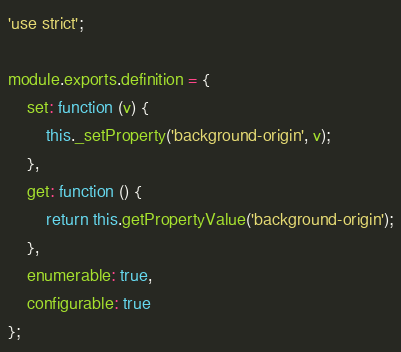Convert code to text. <code><loc_0><loc_0><loc_500><loc_500><_JavaScript_>'use strict';

module.exports.definition = {
    set: function (v) {
        this._setProperty('background-origin', v);
    },
    get: function () {
        return this.getPropertyValue('background-origin');
    },
    enumerable: true,
    configurable: true
};
</code> 